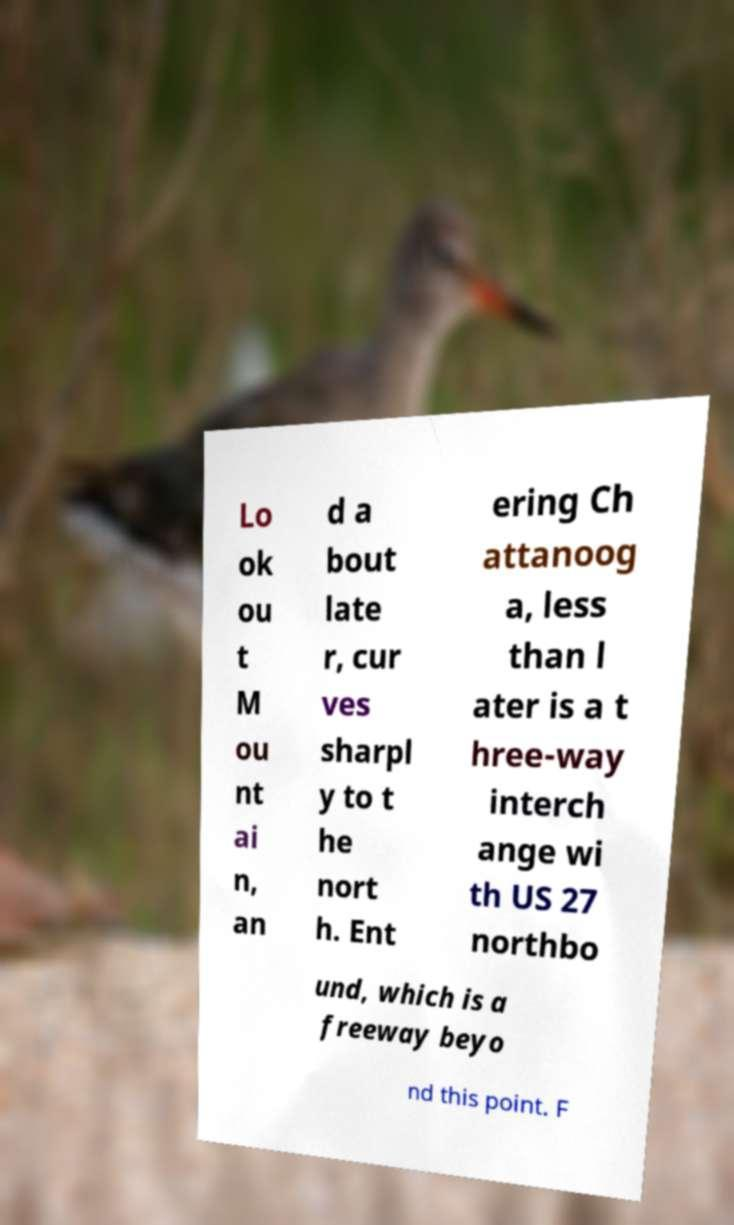For documentation purposes, I need the text within this image transcribed. Could you provide that? Lo ok ou t M ou nt ai n, an d a bout late r, cur ves sharpl y to t he nort h. Ent ering Ch attanoog a, less than l ater is a t hree-way interch ange wi th US 27 northbo und, which is a freeway beyo nd this point. F 